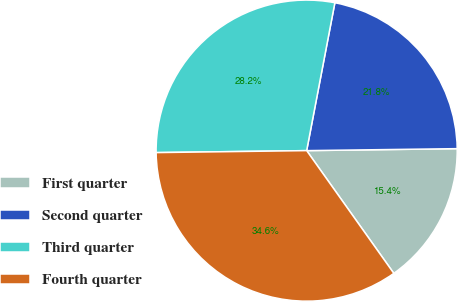Convert chart. <chart><loc_0><loc_0><loc_500><loc_500><pie_chart><fcel>First quarter<fcel>Second quarter<fcel>Third quarter<fcel>Fourth quarter<nl><fcel>15.38%<fcel>21.79%<fcel>28.21%<fcel>34.62%<nl></chart> 